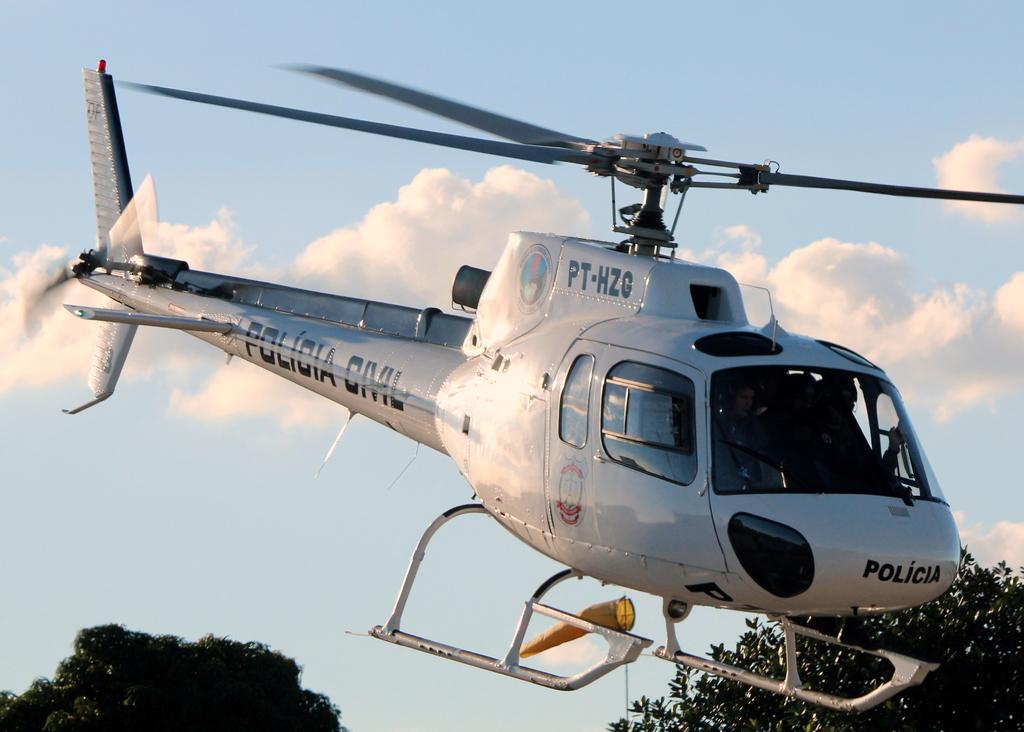Can you describe this image briefly? In this picture there is a man who is driving a helicopter. At the bottom I can see the trees. In the background I can see the sky and clouds. 